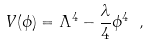Convert formula to latex. <formula><loc_0><loc_0><loc_500><loc_500>V ( \phi ) = \Lambda ^ { 4 } - \frac { \lambda } { 4 } \phi ^ { 4 } \ ,</formula> 